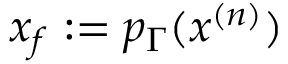<formula> <loc_0><loc_0><loc_500><loc_500>x _ { f } \colon = p _ { \Gamma } ( x ^ { ( n ) } )</formula> 